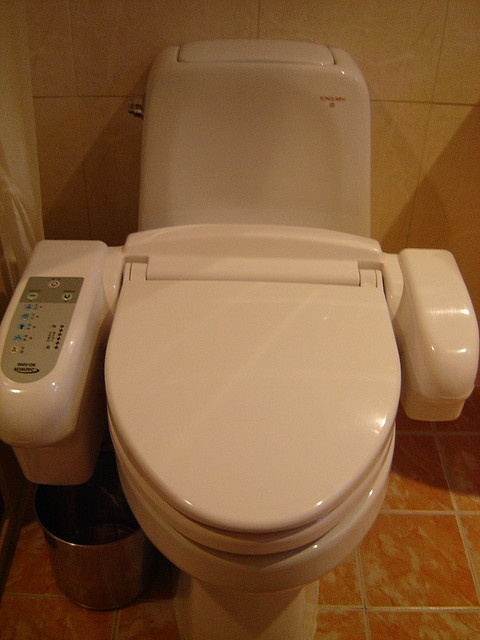Describe the objects in this image and their specific colors. I can see a toilet in maroon, tan, gray, and brown tones in this image. 